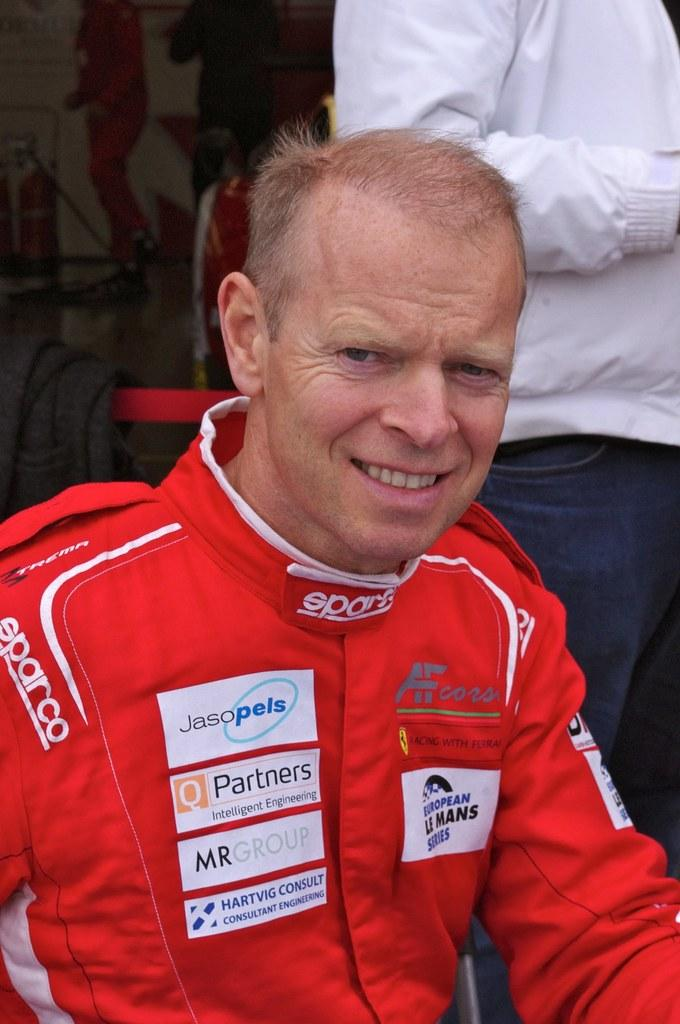<image>
Share a concise interpretation of the image provided. a man sitting with a sparco jacket on themselves 